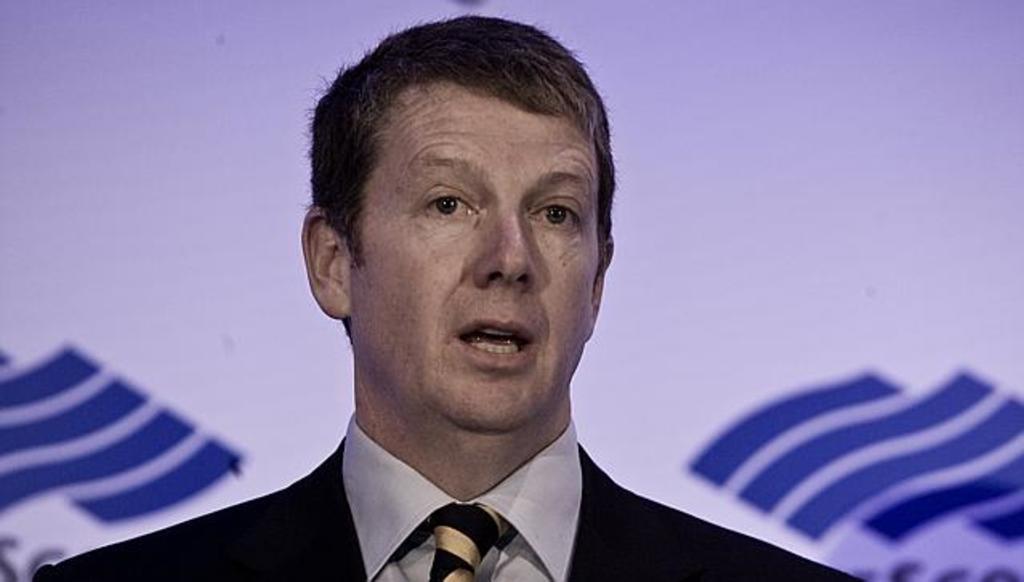Could you give a brief overview of what you see in this image? In this image we can see a man. In the background we can see the banner. 